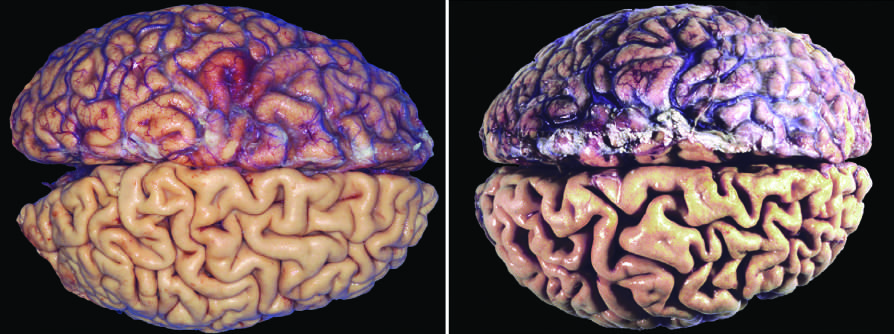what have the meninges been stripped from?
Answer the question using a single word or phrase. The bottom half of each specimen 